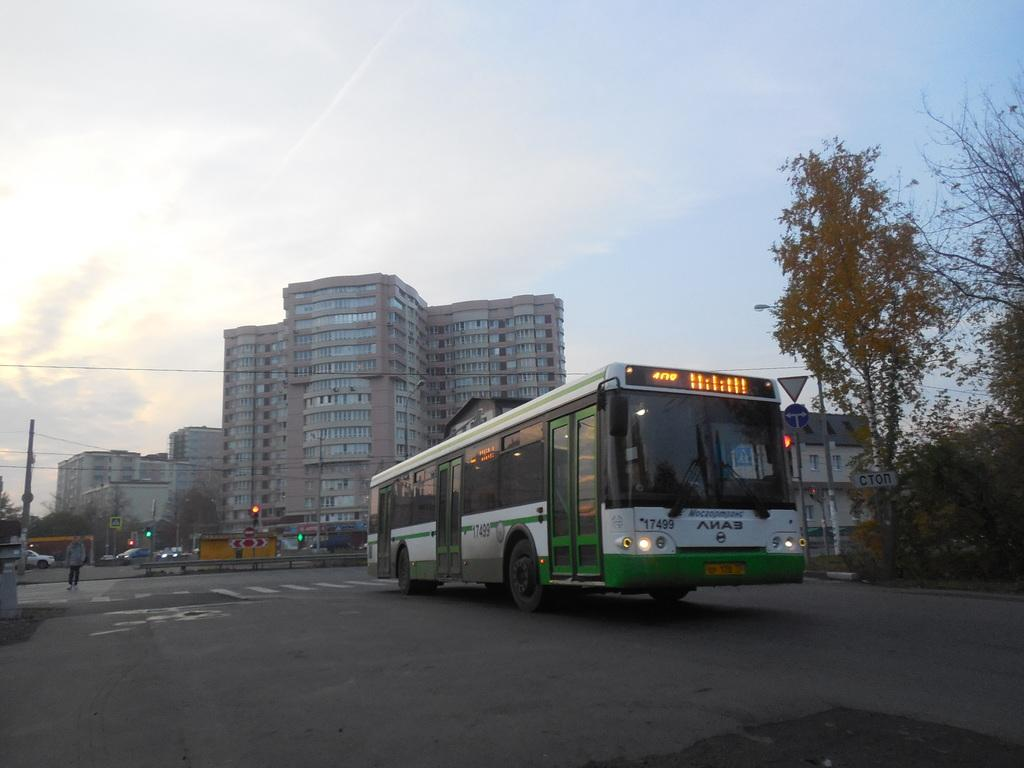What is the main subject of the image? The main subject of the image is a bus. What features can be seen on the bus? The bus has doors and glass. Where is the bus located in the image? The bus is on the road. Is there anyone else present in the image besides the bus? Yes, there is a person on the road. What can be seen in the background of the image? The sky is visible in the image. What type of cake can be seen on the bus in the image? There is no cake present on the bus in the image. What kind of ornament is hanging from the bus's rearview mirror? There is no ornament visible in the image, as it only shows a bus with doors and glass on the road. 